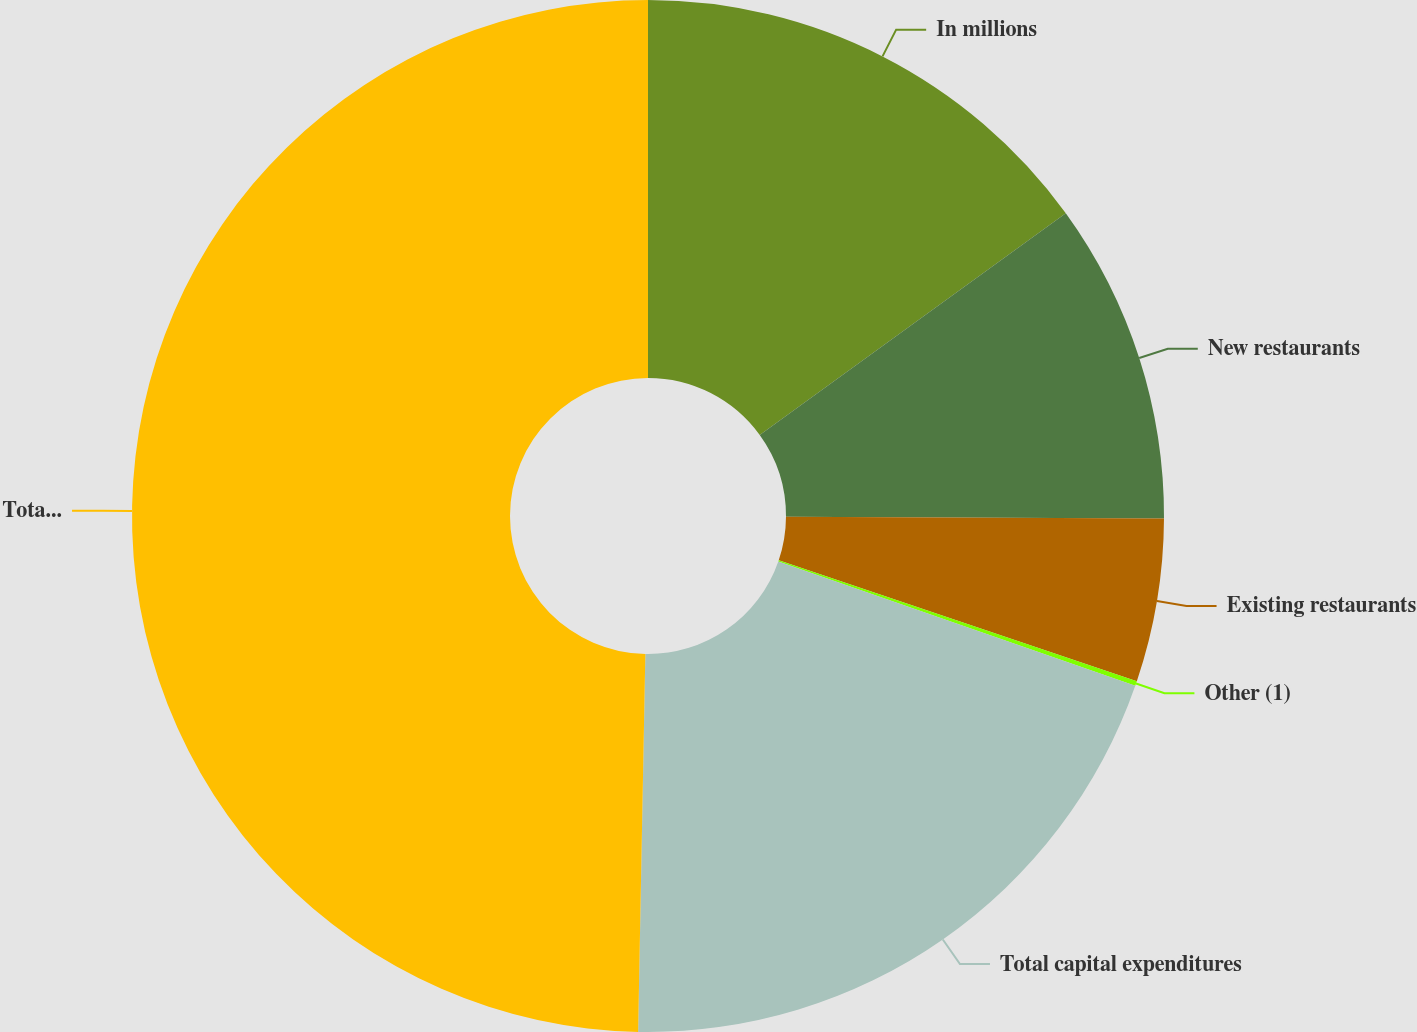Convert chart to OTSL. <chart><loc_0><loc_0><loc_500><loc_500><pie_chart><fcel>In millions<fcel>New restaurants<fcel>Existing restaurants<fcel>Other (1)<fcel>Total capital expenditures<fcel>Total assets<nl><fcel>15.02%<fcel>10.06%<fcel>5.11%<fcel>0.15%<fcel>19.97%<fcel>49.7%<nl></chart> 